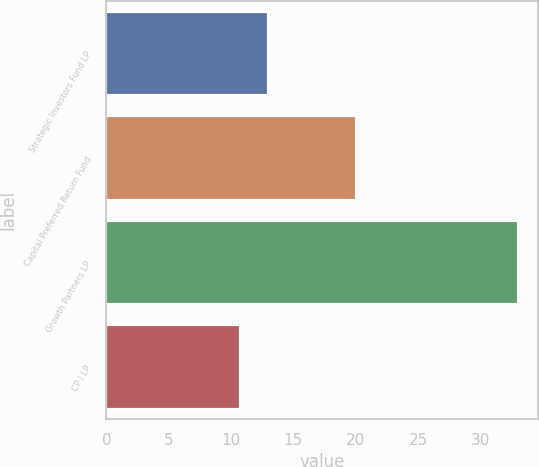<chart> <loc_0><loc_0><loc_500><loc_500><bar_chart><fcel>Strategic Investors Fund LP<fcel>Capital Preferred Return Fund<fcel>Growth Partners LP<fcel>CP I LP<nl><fcel>12.93<fcel>20<fcel>33<fcel>10.7<nl></chart> 